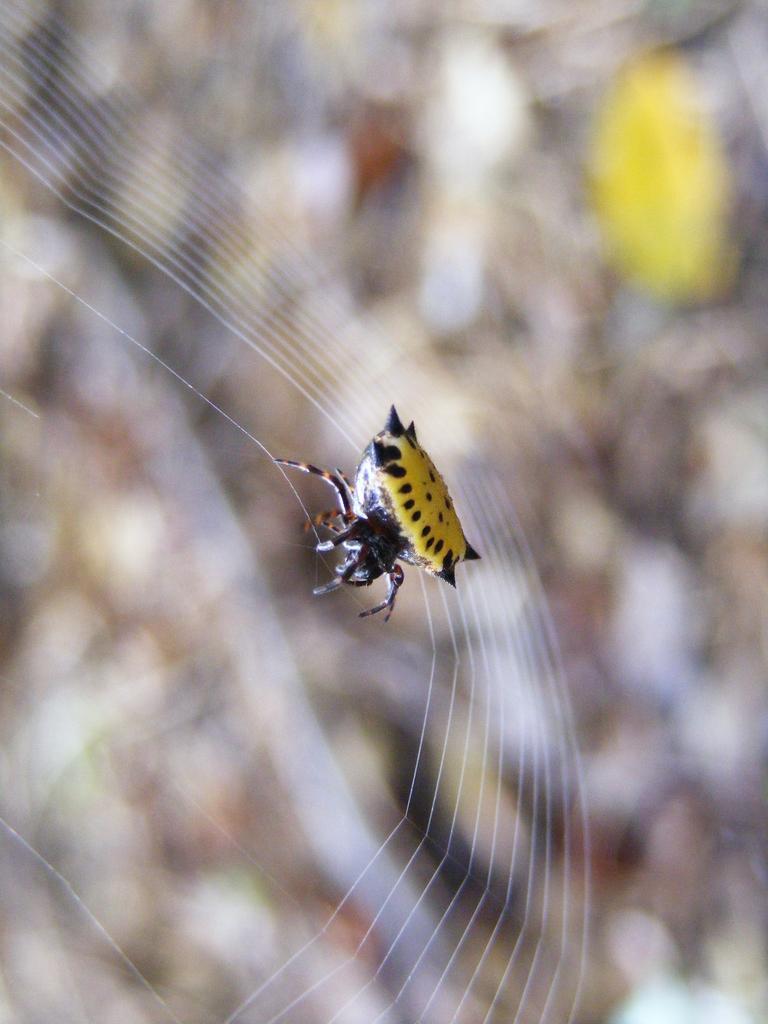Please provide a concise description of this image. In this image we can see a insect and a web. 